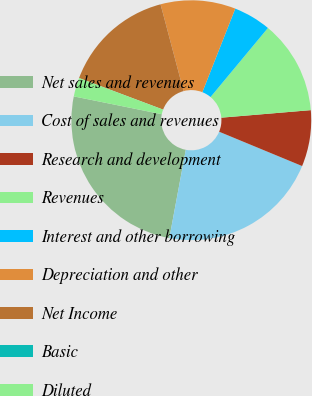Convert chart to OTSL. <chart><loc_0><loc_0><loc_500><loc_500><pie_chart><fcel>Net sales and revenues<fcel>Cost of sales and revenues<fcel>Research and development<fcel>Revenues<fcel>Interest and other borrowing<fcel>Depreciation and other<fcel>Net Income<fcel>Basic<fcel>Diluted<nl><fcel>25.25%<fcel>21.69%<fcel>7.58%<fcel>12.63%<fcel>5.06%<fcel>10.1%<fcel>15.15%<fcel>0.01%<fcel>2.53%<nl></chart> 